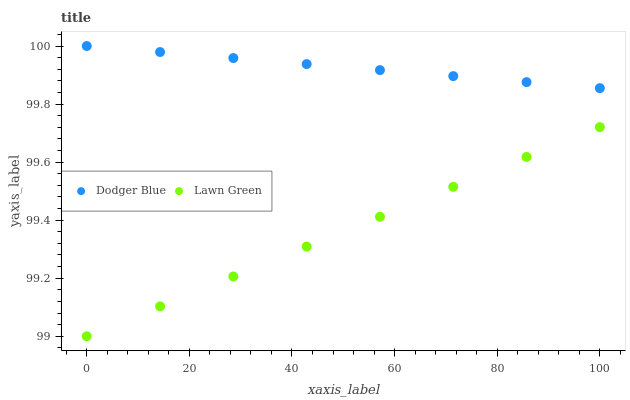Does Lawn Green have the minimum area under the curve?
Answer yes or no. Yes. Does Dodger Blue have the maximum area under the curve?
Answer yes or no. Yes. Does Dodger Blue have the minimum area under the curve?
Answer yes or no. No. Is Lawn Green the smoothest?
Answer yes or no. Yes. Is Dodger Blue the roughest?
Answer yes or no. Yes. Is Dodger Blue the smoothest?
Answer yes or no. No. Does Lawn Green have the lowest value?
Answer yes or no. Yes. Does Dodger Blue have the lowest value?
Answer yes or no. No. Does Dodger Blue have the highest value?
Answer yes or no. Yes. Is Lawn Green less than Dodger Blue?
Answer yes or no. Yes. Is Dodger Blue greater than Lawn Green?
Answer yes or no. Yes. Does Lawn Green intersect Dodger Blue?
Answer yes or no. No. 